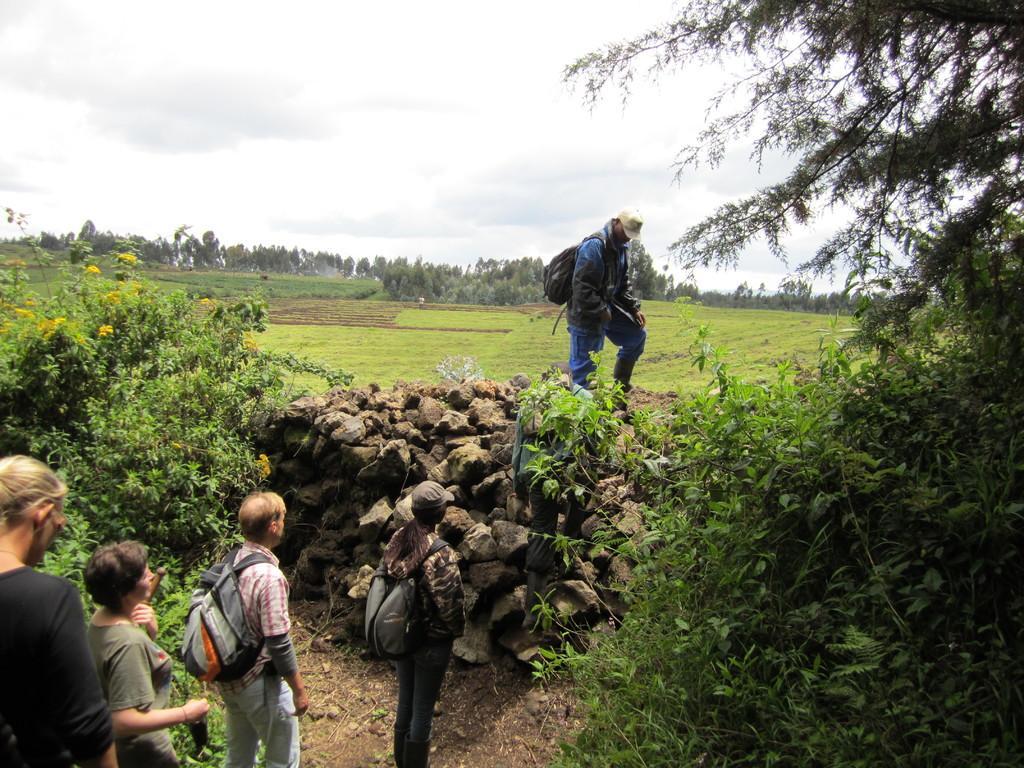How would you summarize this image in a sentence or two? The picture is taken in a field. In the foreground of the picture there are trees, stones, people and sand. In the center of the picture there are fields and trees. Sky is cloudy. 